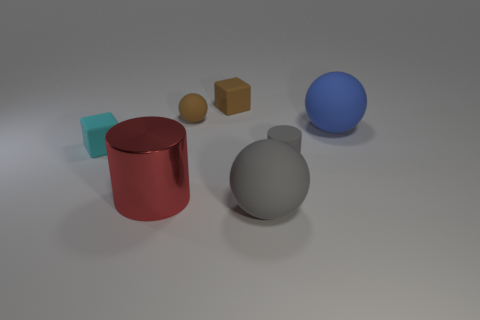How many green objects are matte spheres or big objects?
Keep it short and to the point. 0. The block that is the same color as the small ball is what size?
Your answer should be very brief. Small. There is a red object; how many blue spheres are on the right side of it?
Your answer should be very brief. 1. There is a red metal object that is in front of the large sphere that is on the right side of the rubber ball that is in front of the blue sphere; how big is it?
Offer a very short reply. Large. Are there any rubber balls right of the small gray cylinder that is on the right side of the brown rubber thing that is left of the brown matte cube?
Provide a succinct answer. Yes. Are there more green rubber objects than small brown spheres?
Offer a very short reply. No. There is a object that is to the left of the red cylinder; what color is it?
Your response must be concise. Cyan. Are there more matte things that are behind the rubber cylinder than green matte spheres?
Your answer should be very brief. Yes. Is the brown sphere made of the same material as the blue sphere?
Your answer should be very brief. Yes. What number of other objects are there of the same shape as the cyan matte object?
Keep it short and to the point. 1. 